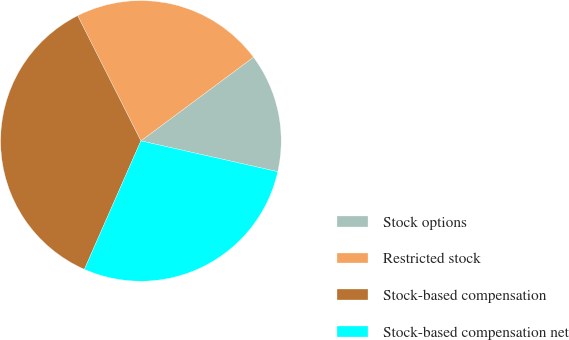<chart> <loc_0><loc_0><loc_500><loc_500><pie_chart><fcel>Stock options<fcel>Restricted stock<fcel>Stock-based compensation<fcel>Stock-based compensation net<nl><fcel>13.69%<fcel>22.27%<fcel>35.96%<fcel>28.08%<nl></chart> 